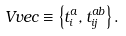Convert formula to latex. <formula><loc_0><loc_0><loc_500><loc_500>\ V v e c \equiv \left \{ t _ { i } ^ { a } , t _ { i j } ^ { a b } \right \} .</formula> 